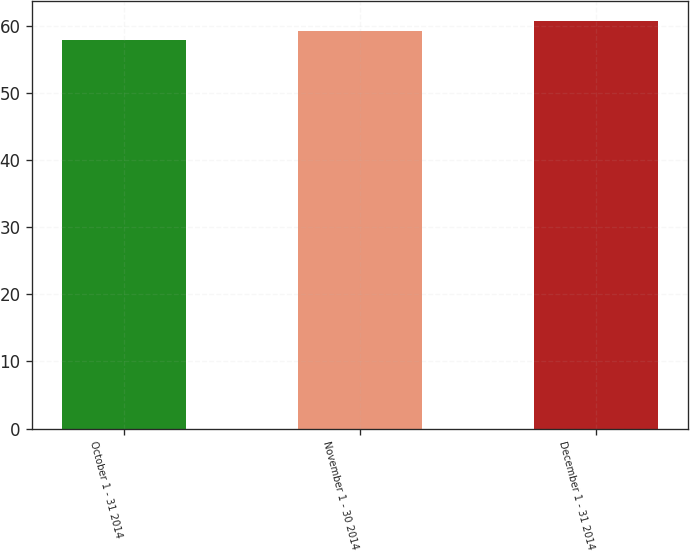Convert chart to OTSL. <chart><loc_0><loc_0><loc_500><loc_500><bar_chart><fcel>October 1 - 31 2014<fcel>November 1 - 30 2014<fcel>December 1 - 31 2014<nl><fcel>58.02<fcel>59.25<fcel>60.78<nl></chart> 